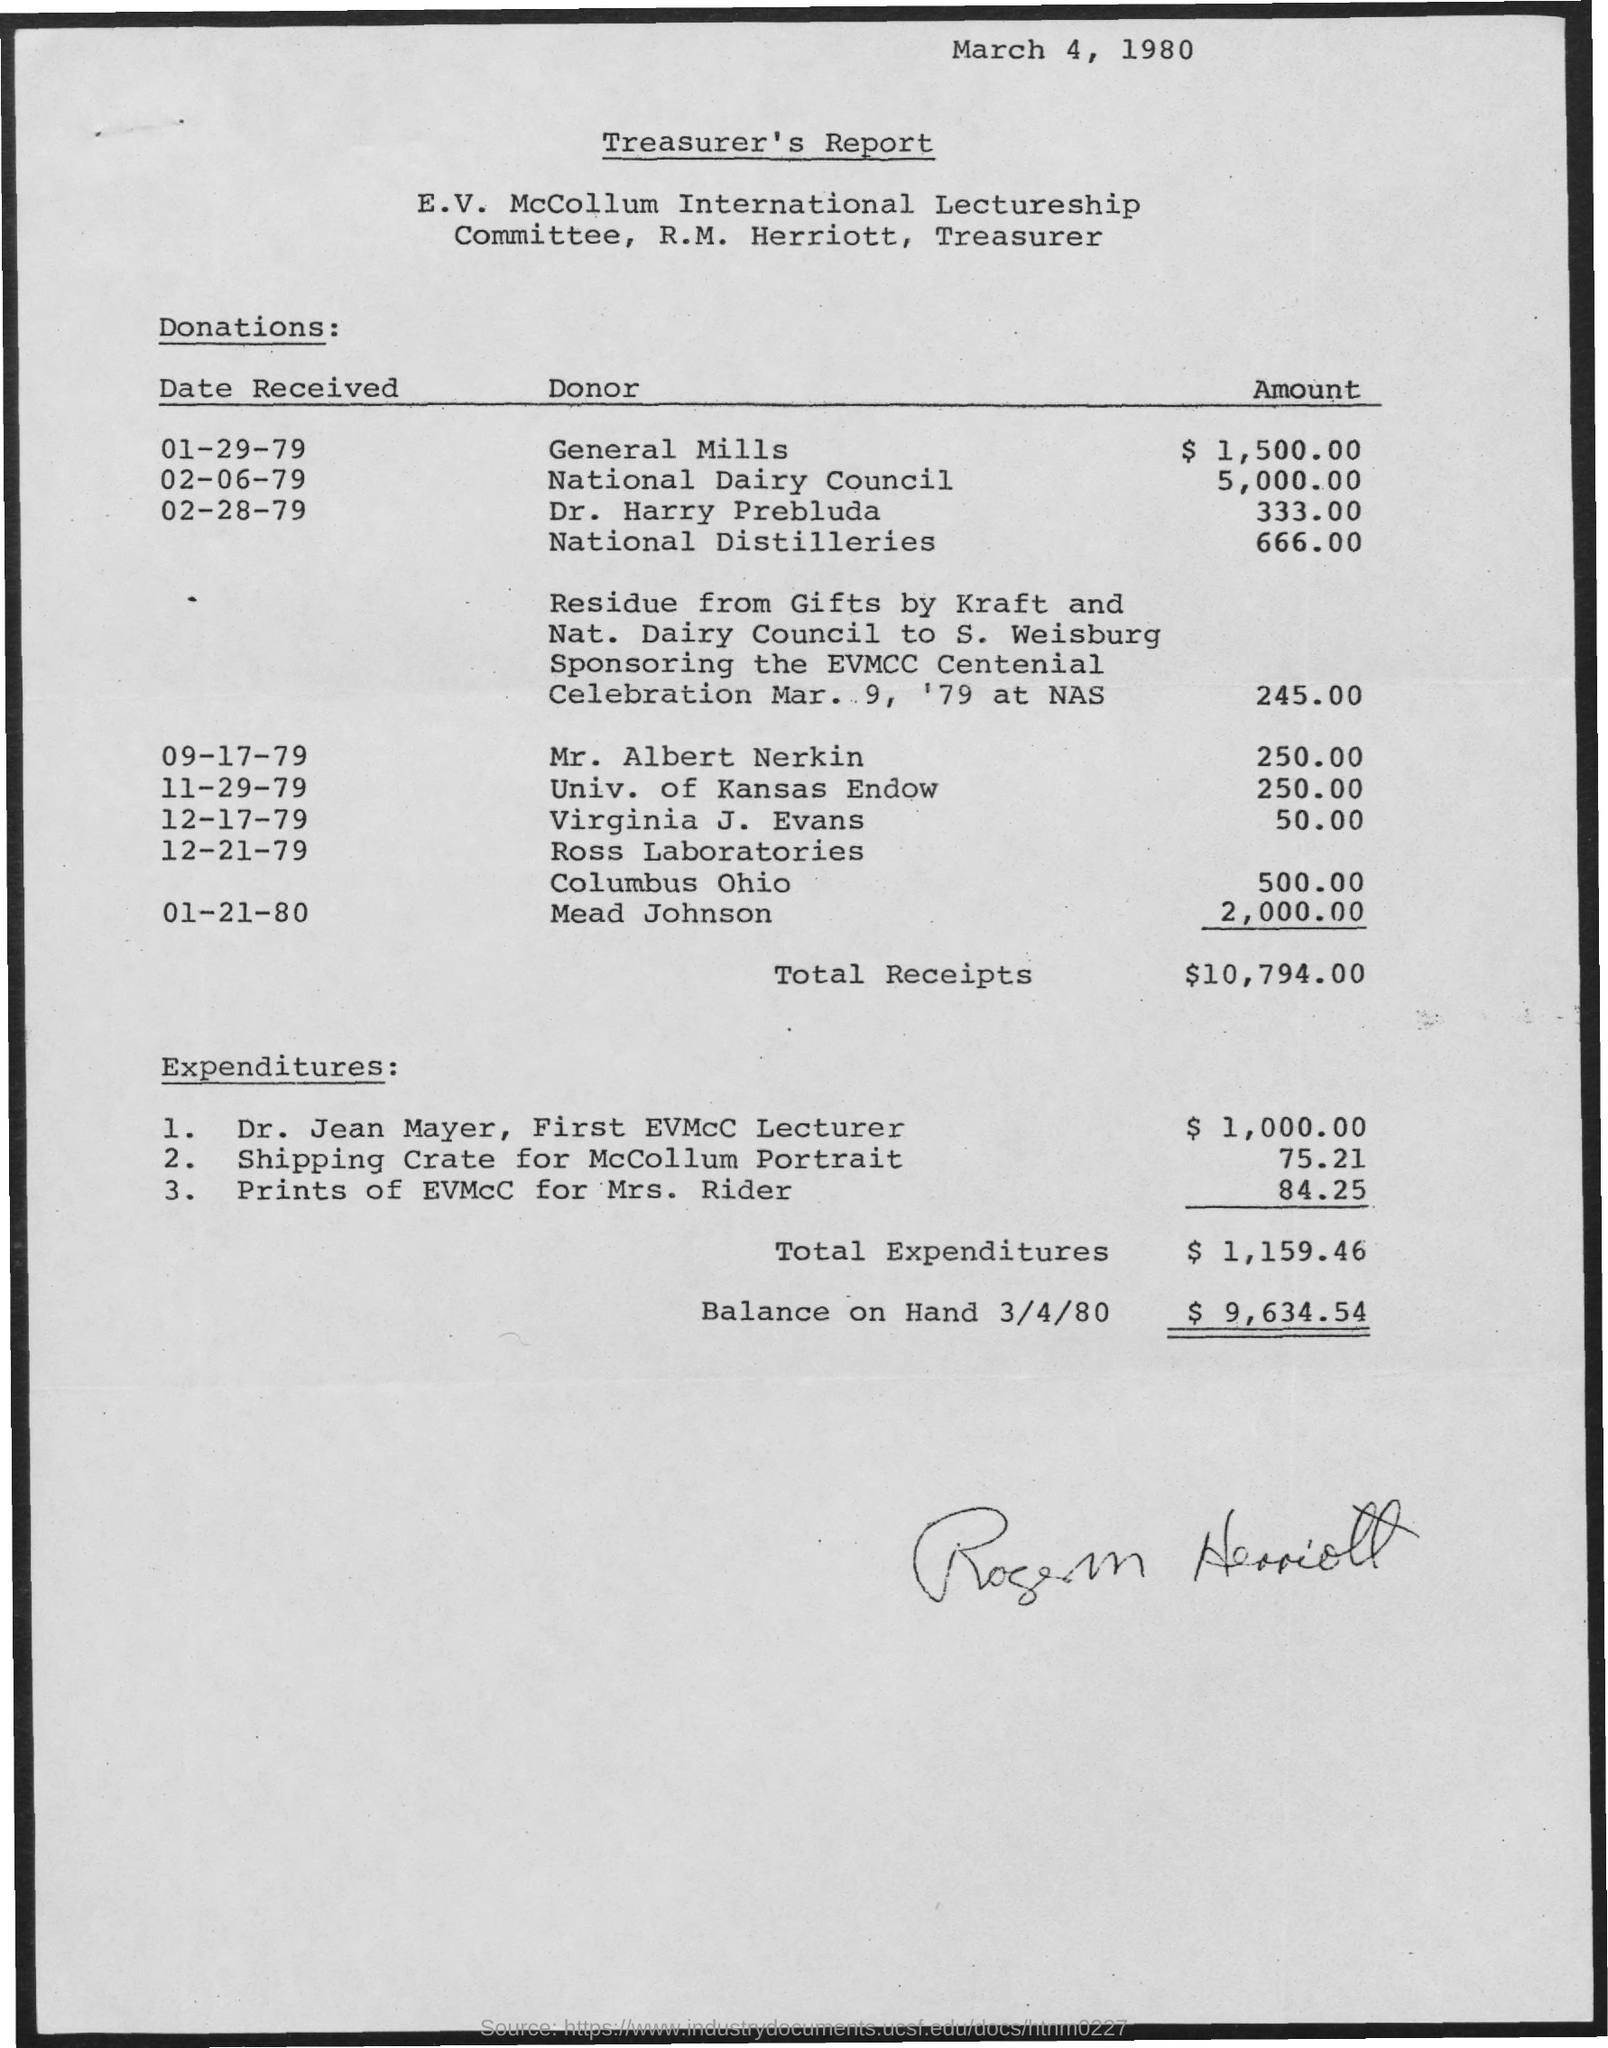What is the amount donated by general mills mentioned ?
Offer a very short reply. $1,500.00. What is the amount donated by national dairy council ?
Give a very brief answer. 5,000.00. What is the amount donated by national distilleries ?
Your response must be concise. 666.00. What is the amount of  total receipts mentioned ?
Your answer should be very brief. $10,794.00. What is the amount of total expenditures mentioned ?
Your response must be concise. $ 1,159.46. What is the amount of balance on hand 3/4/80 as mentioned ?
Ensure brevity in your answer.  $ 9,634.54. What  is the amount donated by mead johnson mentioned ?
Provide a succinct answer. 2,000.00. 